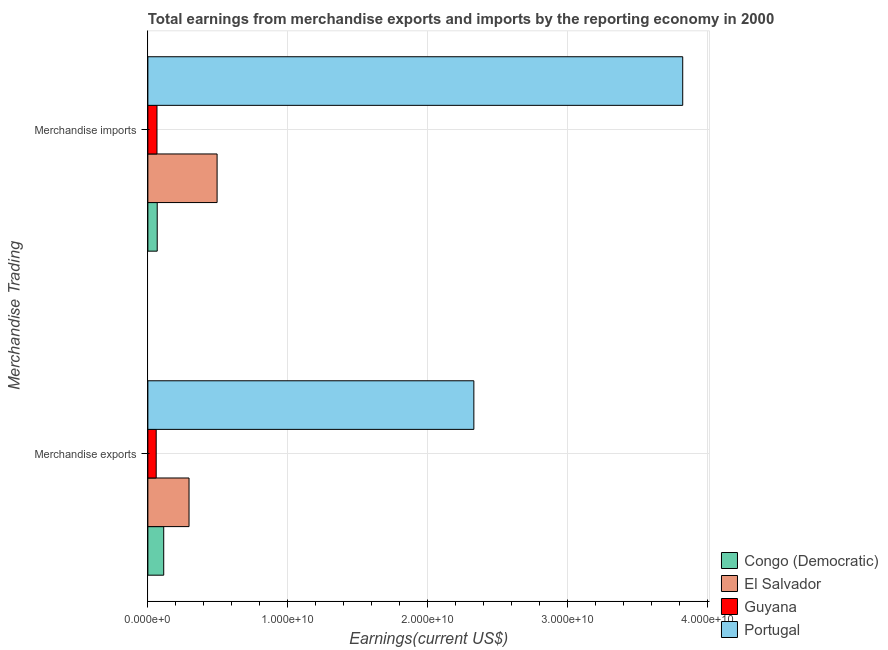How many groups of bars are there?
Ensure brevity in your answer.  2. Are the number of bars per tick equal to the number of legend labels?
Keep it short and to the point. Yes. Are the number of bars on each tick of the Y-axis equal?
Give a very brief answer. Yes. What is the earnings from merchandise imports in El Salvador?
Offer a terse response. 4.95e+09. Across all countries, what is the maximum earnings from merchandise exports?
Give a very brief answer. 2.33e+1. Across all countries, what is the minimum earnings from merchandise imports?
Give a very brief answer. 6.51e+08. In which country was the earnings from merchandise imports minimum?
Give a very brief answer. Guyana. What is the total earnings from merchandise exports in the graph?
Offer a very short reply. 2.80e+1. What is the difference between the earnings from merchandise imports in Guyana and that in Portugal?
Your response must be concise. -3.76e+1. What is the difference between the earnings from merchandise exports in Portugal and the earnings from merchandise imports in Congo (Democratic)?
Provide a succinct answer. 2.26e+1. What is the average earnings from merchandise imports per country?
Give a very brief answer. 1.11e+1. What is the difference between the earnings from merchandise imports and earnings from merchandise exports in Portugal?
Ensure brevity in your answer.  1.49e+1. What is the ratio of the earnings from merchandise imports in Guyana to that in El Salvador?
Ensure brevity in your answer.  0.13. Is the earnings from merchandise imports in El Salvador less than that in Portugal?
Keep it short and to the point. Yes. What does the 4th bar from the top in Merchandise imports represents?
Ensure brevity in your answer.  Congo (Democratic). What does the 2nd bar from the bottom in Merchandise imports represents?
Ensure brevity in your answer.  El Salvador. Does the graph contain grids?
Give a very brief answer. Yes. Where does the legend appear in the graph?
Provide a succinct answer. Bottom right. What is the title of the graph?
Keep it short and to the point. Total earnings from merchandise exports and imports by the reporting economy in 2000. Does "Mauritania" appear as one of the legend labels in the graph?
Offer a very short reply. No. What is the label or title of the X-axis?
Offer a terse response. Earnings(current US$). What is the label or title of the Y-axis?
Provide a succinct answer. Merchandise Trading. What is the Earnings(current US$) of Congo (Democratic) in Merchandise exports?
Provide a succinct answer. 1.13e+09. What is the Earnings(current US$) of El Salvador in Merchandise exports?
Give a very brief answer. 2.94e+09. What is the Earnings(current US$) in Guyana in Merchandise exports?
Keep it short and to the point. 5.96e+08. What is the Earnings(current US$) in Portugal in Merchandise exports?
Make the answer very short. 2.33e+1. What is the Earnings(current US$) of Congo (Democratic) in Merchandise imports?
Make the answer very short. 6.68e+08. What is the Earnings(current US$) of El Salvador in Merchandise imports?
Your answer should be compact. 4.95e+09. What is the Earnings(current US$) in Guyana in Merchandise imports?
Your response must be concise. 6.51e+08. What is the Earnings(current US$) of Portugal in Merchandise imports?
Give a very brief answer. 3.82e+1. Across all Merchandise Trading, what is the maximum Earnings(current US$) in Congo (Democratic)?
Offer a very short reply. 1.13e+09. Across all Merchandise Trading, what is the maximum Earnings(current US$) in El Salvador?
Offer a very short reply. 4.95e+09. Across all Merchandise Trading, what is the maximum Earnings(current US$) in Guyana?
Your response must be concise. 6.51e+08. Across all Merchandise Trading, what is the maximum Earnings(current US$) of Portugal?
Provide a short and direct response. 3.82e+1. Across all Merchandise Trading, what is the minimum Earnings(current US$) in Congo (Democratic)?
Your response must be concise. 6.68e+08. Across all Merchandise Trading, what is the minimum Earnings(current US$) in El Salvador?
Offer a very short reply. 2.94e+09. Across all Merchandise Trading, what is the minimum Earnings(current US$) in Guyana?
Your answer should be compact. 5.96e+08. Across all Merchandise Trading, what is the minimum Earnings(current US$) in Portugal?
Provide a short and direct response. 2.33e+1. What is the total Earnings(current US$) of Congo (Democratic) in the graph?
Make the answer very short. 1.80e+09. What is the total Earnings(current US$) in El Salvador in the graph?
Give a very brief answer. 7.89e+09. What is the total Earnings(current US$) of Guyana in the graph?
Your response must be concise. 1.25e+09. What is the total Earnings(current US$) in Portugal in the graph?
Make the answer very short. 6.15e+1. What is the difference between the Earnings(current US$) in Congo (Democratic) in Merchandise exports and that in Merchandise imports?
Provide a short and direct response. 4.65e+08. What is the difference between the Earnings(current US$) in El Salvador in Merchandise exports and that in Merchandise imports?
Ensure brevity in your answer.  -2.01e+09. What is the difference between the Earnings(current US$) in Guyana in Merchandise exports and that in Merchandise imports?
Offer a very short reply. -5.51e+07. What is the difference between the Earnings(current US$) of Portugal in Merchandise exports and that in Merchandise imports?
Your response must be concise. -1.49e+1. What is the difference between the Earnings(current US$) in Congo (Democratic) in Merchandise exports and the Earnings(current US$) in El Salvador in Merchandise imports?
Ensure brevity in your answer.  -3.81e+09. What is the difference between the Earnings(current US$) in Congo (Democratic) in Merchandise exports and the Earnings(current US$) in Guyana in Merchandise imports?
Offer a terse response. 4.82e+08. What is the difference between the Earnings(current US$) of Congo (Democratic) in Merchandise exports and the Earnings(current US$) of Portugal in Merchandise imports?
Offer a very short reply. -3.71e+1. What is the difference between the Earnings(current US$) in El Salvador in Merchandise exports and the Earnings(current US$) in Guyana in Merchandise imports?
Make the answer very short. 2.29e+09. What is the difference between the Earnings(current US$) of El Salvador in Merchandise exports and the Earnings(current US$) of Portugal in Merchandise imports?
Offer a very short reply. -3.53e+1. What is the difference between the Earnings(current US$) in Guyana in Merchandise exports and the Earnings(current US$) in Portugal in Merchandise imports?
Your answer should be compact. -3.76e+1. What is the average Earnings(current US$) in Congo (Democratic) per Merchandise Trading?
Provide a succinct answer. 9.01e+08. What is the average Earnings(current US$) of El Salvador per Merchandise Trading?
Make the answer very short. 3.94e+09. What is the average Earnings(current US$) of Guyana per Merchandise Trading?
Ensure brevity in your answer.  6.23e+08. What is the average Earnings(current US$) of Portugal per Merchandise Trading?
Keep it short and to the point. 3.08e+1. What is the difference between the Earnings(current US$) of Congo (Democratic) and Earnings(current US$) of El Salvador in Merchandise exports?
Provide a short and direct response. -1.81e+09. What is the difference between the Earnings(current US$) of Congo (Democratic) and Earnings(current US$) of Guyana in Merchandise exports?
Give a very brief answer. 5.37e+08. What is the difference between the Earnings(current US$) of Congo (Democratic) and Earnings(current US$) of Portugal in Merchandise exports?
Ensure brevity in your answer.  -2.22e+1. What is the difference between the Earnings(current US$) in El Salvador and Earnings(current US$) in Guyana in Merchandise exports?
Offer a terse response. 2.35e+09. What is the difference between the Earnings(current US$) of El Salvador and Earnings(current US$) of Portugal in Merchandise exports?
Ensure brevity in your answer.  -2.04e+1. What is the difference between the Earnings(current US$) in Guyana and Earnings(current US$) in Portugal in Merchandise exports?
Make the answer very short. -2.27e+1. What is the difference between the Earnings(current US$) of Congo (Democratic) and Earnings(current US$) of El Salvador in Merchandise imports?
Your response must be concise. -4.28e+09. What is the difference between the Earnings(current US$) of Congo (Democratic) and Earnings(current US$) of Guyana in Merchandise imports?
Provide a succinct answer. 1.71e+07. What is the difference between the Earnings(current US$) of Congo (Democratic) and Earnings(current US$) of Portugal in Merchandise imports?
Your answer should be compact. -3.76e+1. What is the difference between the Earnings(current US$) of El Salvador and Earnings(current US$) of Guyana in Merchandise imports?
Offer a terse response. 4.30e+09. What is the difference between the Earnings(current US$) in El Salvador and Earnings(current US$) in Portugal in Merchandise imports?
Provide a succinct answer. -3.33e+1. What is the difference between the Earnings(current US$) of Guyana and Earnings(current US$) of Portugal in Merchandise imports?
Offer a very short reply. -3.76e+1. What is the ratio of the Earnings(current US$) of Congo (Democratic) in Merchandise exports to that in Merchandise imports?
Make the answer very short. 1.7. What is the ratio of the Earnings(current US$) in El Salvador in Merchandise exports to that in Merchandise imports?
Your answer should be very brief. 0.59. What is the ratio of the Earnings(current US$) in Guyana in Merchandise exports to that in Merchandise imports?
Keep it short and to the point. 0.92. What is the ratio of the Earnings(current US$) of Portugal in Merchandise exports to that in Merchandise imports?
Your response must be concise. 0.61. What is the difference between the highest and the second highest Earnings(current US$) of Congo (Democratic)?
Keep it short and to the point. 4.65e+08. What is the difference between the highest and the second highest Earnings(current US$) in El Salvador?
Offer a terse response. 2.01e+09. What is the difference between the highest and the second highest Earnings(current US$) of Guyana?
Offer a very short reply. 5.51e+07. What is the difference between the highest and the second highest Earnings(current US$) in Portugal?
Provide a short and direct response. 1.49e+1. What is the difference between the highest and the lowest Earnings(current US$) in Congo (Democratic)?
Provide a succinct answer. 4.65e+08. What is the difference between the highest and the lowest Earnings(current US$) in El Salvador?
Ensure brevity in your answer.  2.01e+09. What is the difference between the highest and the lowest Earnings(current US$) in Guyana?
Ensure brevity in your answer.  5.51e+07. What is the difference between the highest and the lowest Earnings(current US$) in Portugal?
Provide a succinct answer. 1.49e+1. 